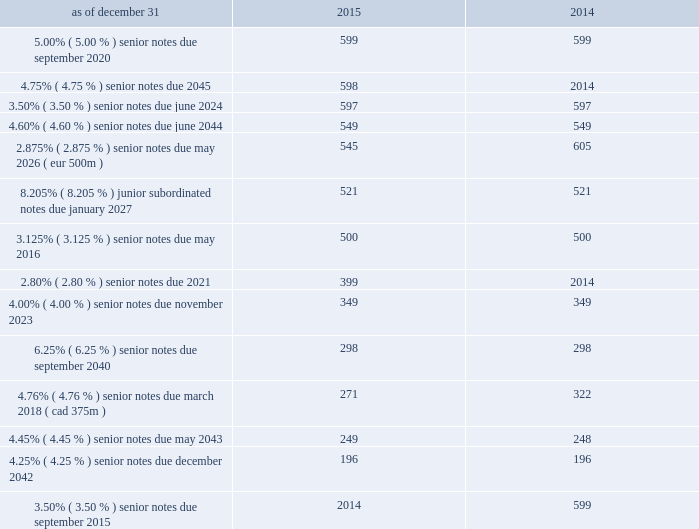Debt the following is a summary of outstanding debt ( in millions ) : .
Revolving credit facilities as of december 31 , 2015 , aon plc had two committed credit facilities outstanding : its $ 400 million u.s .
Credit facility expiring in march 2017 ( the "2017 facility" ) and $ 900 million multi-currency u.s .
Credit facility expiring in february 2020 ( the "2020 facility" ) .
The 2020 facility was entered into on february 2 , 2015 and replaced the previous 20ac650 million european credit facility .
Effective february 2 , 2016 , the 2020 facility terms were extended for 1 year and will expire in february 2021 .
Each of these facilities included customary representations , warranties and covenants , including financial covenants that require aon plc to maintain specified ratios of adjusted consolidated ebitda to consolidated interest expense and consolidated debt to adjusted consolidated ebitda , in each case , tested quarterly .
At december 31 , 2015 , aon plc did not have borrowings under either the 2017 facility or the 2020 facility , and was in compliance with these financial covenants and all other covenants contained therein during the twelve months ended december 31 , 2015 .
On november 13 , 2015 , aon plc issued $ 400 million of 2.80% ( 2.80 % ) senior notes due march 2021 .
We used the proceeds of the issuance for general corporate purposes .
On september 30 , 2015 , $ 600 million of 3.50% ( 3.50 % ) senior notes issued by aon corporation matured and were repaid .
On may 20 , 2015 , the aon plc issued $ 600 million of 4.750% ( 4.750 % ) senior notes due may 2045 .
The company used the proceeds of the issuance for general corporate purposes .
On august 12 , 2014 , aon plc issued $ 350 million of 3.50% ( 3.50 % ) senior notes due june 2024 .
The 3.50% ( 3.50 % ) notes due 2024 constitute a further issuance of , and were consolidated to form a single series of debt securities with , the $ 250 million of 3.50% ( 3.50 % ) notes due june 2024 that was issued by aon plc on may 20 , 2014 concurrently with aon plc's issuance of $ 550 million of 4.60% ( 4.60 % ) notes due june 2044 .
Aon plc used the proceeds from these issuances for working capital and general corporate purposes. .
What is the percentage change in total debt in 2015? 
Computations: ((5737 - 5582) / 5582)
Answer: 0.02777. 